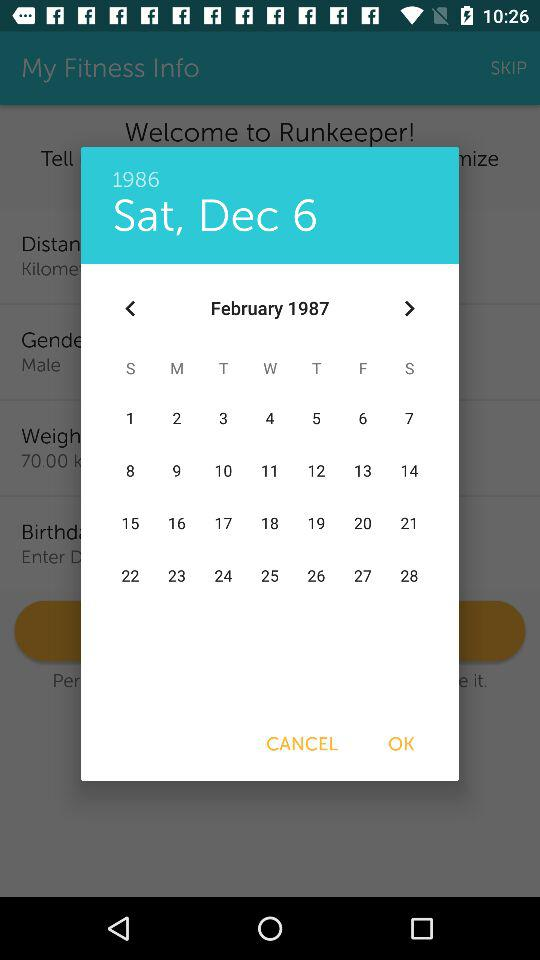What is the selected year? The selected year is 1986. 